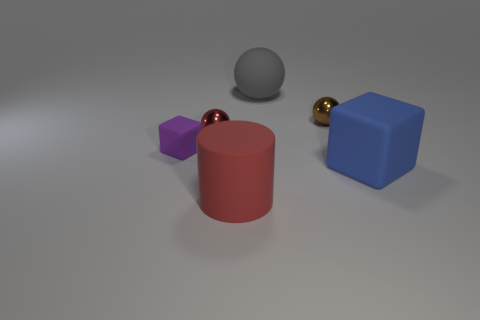There is a rubber object that is the same size as the brown metallic sphere; what color is it?
Ensure brevity in your answer.  Purple. What number of cylinders are either big matte objects or small brown metallic things?
Provide a succinct answer. 1. What number of big brown rubber cylinders are there?
Ensure brevity in your answer.  0. There is a blue thing; does it have the same shape as the small thing in front of the red metallic thing?
Provide a succinct answer. Yes. What size is the thing that is the same color as the large cylinder?
Offer a terse response. Small. How many objects are large gray metal cylinders or big red rubber cylinders?
Keep it short and to the point. 1. The large matte object that is behind the red thing that is to the left of the large matte cylinder is what shape?
Ensure brevity in your answer.  Sphere. There is a red thing that is behind the large cylinder; is it the same shape as the tiny purple object?
Keep it short and to the point. No. What size is the gray ball that is the same material as the purple cube?
Your answer should be very brief. Large. How many things are either large things in front of the big blue object or metallic things behind the purple matte thing?
Offer a terse response. 3. 